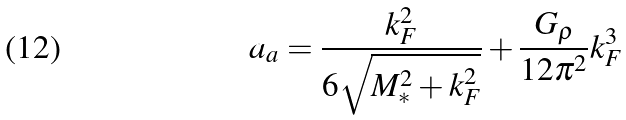Convert formula to latex. <formula><loc_0><loc_0><loc_500><loc_500>a _ { a } = \frac { k ^ { 2 } _ { F } } { 6 \sqrt { M _ { * } ^ { 2 } + k _ { F } ^ { 2 } } } + \frac { G _ { \rho } } { 1 2 \pi ^ { 2 } } k _ { F } ^ { 3 }</formula> 